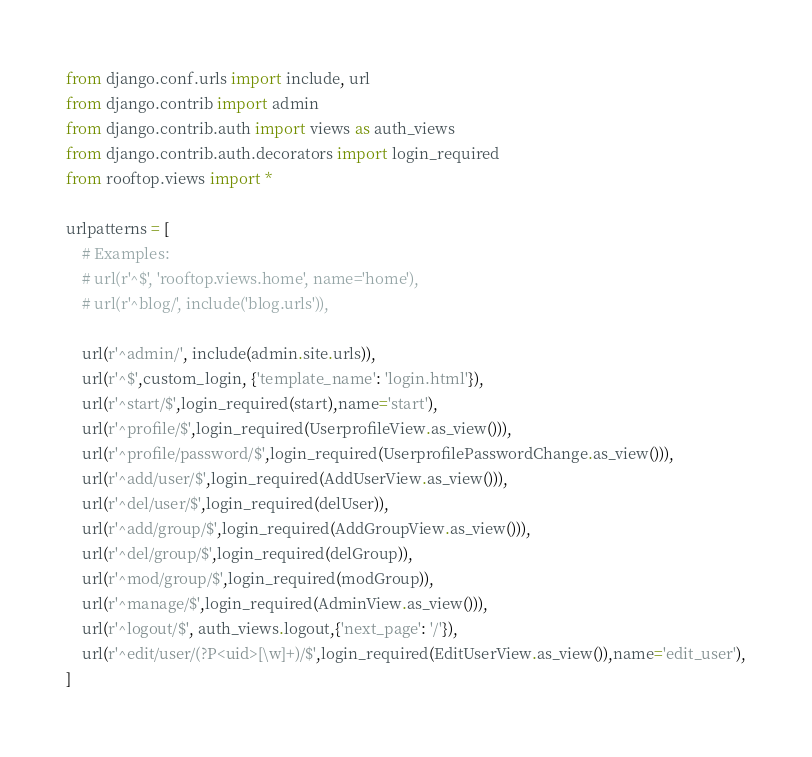Convert code to text. <code><loc_0><loc_0><loc_500><loc_500><_Python_>from django.conf.urls import include, url
from django.contrib import admin
from django.contrib.auth import views as auth_views
from django.contrib.auth.decorators import login_required
from rooftop.views import *

urlpatterns = [
    # Examples:
    # url(r'^$', 'rooftop.views.home', name='home'),
    # url(r'^blog/', include('blog.urls')),

    url(r'^admin/', include(admin.site.urls)),
    url(r'^$',custom_login, {'template_name': 'login.html'}),
    url(r'^start/$',login_required(start),name='start'),
    url(r'^profile/$',login_required(UserprofileView.as_view())),
    url(r'^profile/password/$',login_required(UserprofilePasswordChange.as_view())),
    url(r'^add/user/$',login_required(AddUserView.as_view())),
    url(r'^del/user/$',login_required(delUser)),
    url(r'^add/group/$',login_required(AddGroupView.as_view())),
    url(r'^del/group/$',login_required(delGroup)),
    url(r'^mod/group/$',login_required(modGroup)),
    url(r'^manage/$',login_required(AdminView.as_view())),
    url(r'^logout/$', auth_views.logout,{'next_page': '/'}),
    url(r'^edit/user/(?P<uid>[\w]+)/$',login_required(EditUserView.as_view()),name='edit_user'),
]
</code> 